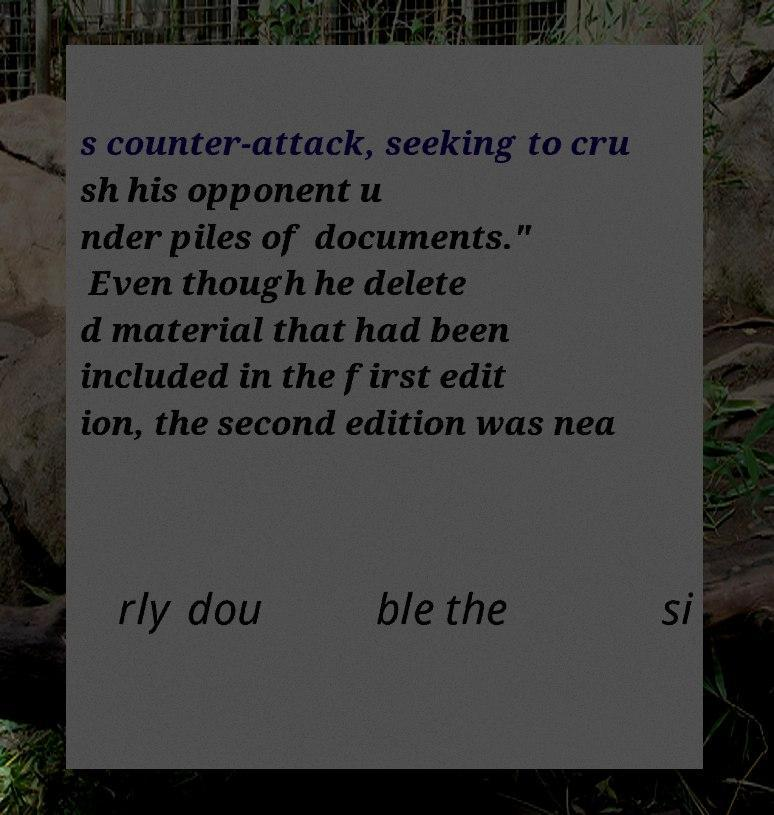Could you assist in decoding the text presented in this image and type it out clearly? s counter-attack, seeking to cru sh his opponent u nder piles of documents." Even though he delete d material that had been included in the first edit ion, the second edition was nea rly dou ble the si 